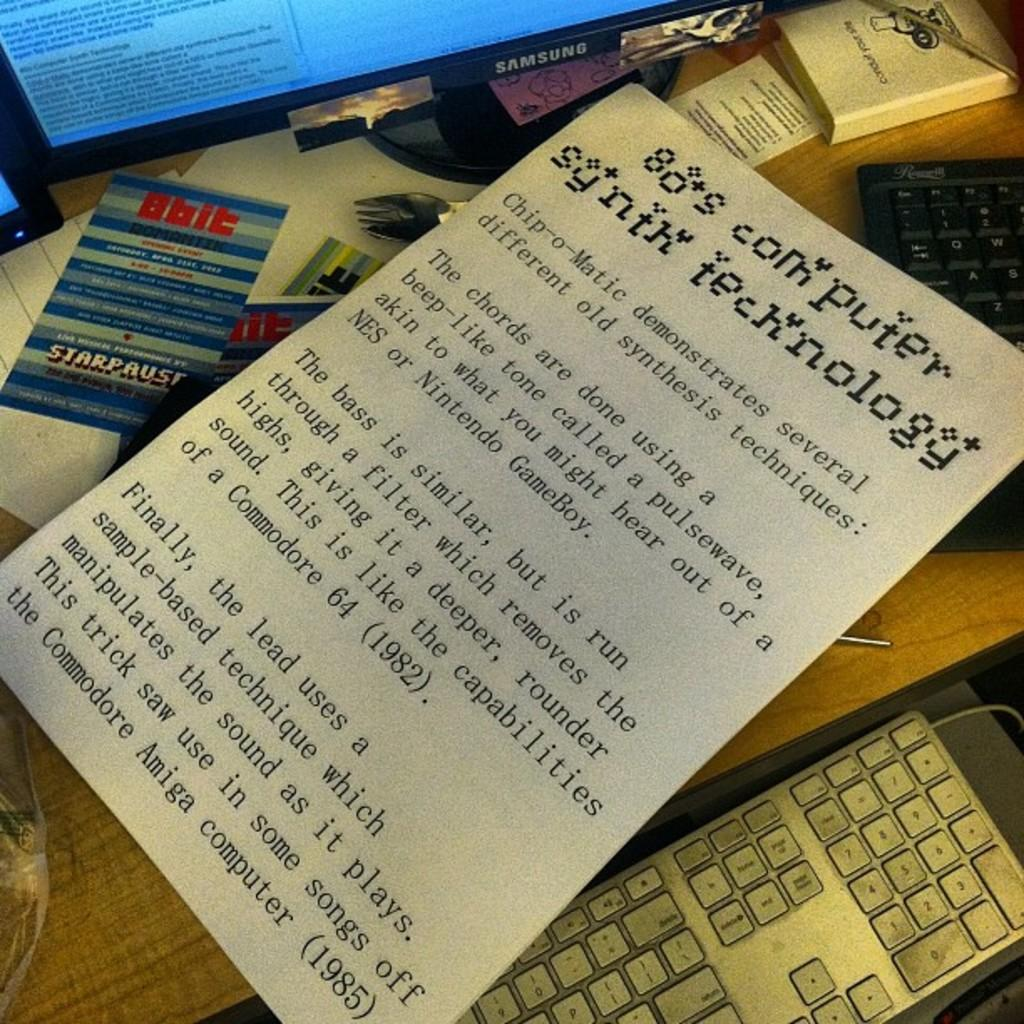<image>
Present a compact description of the photo's key features. A desk with a Samsung computer, a couple of pieces of paper and a keyboard. 